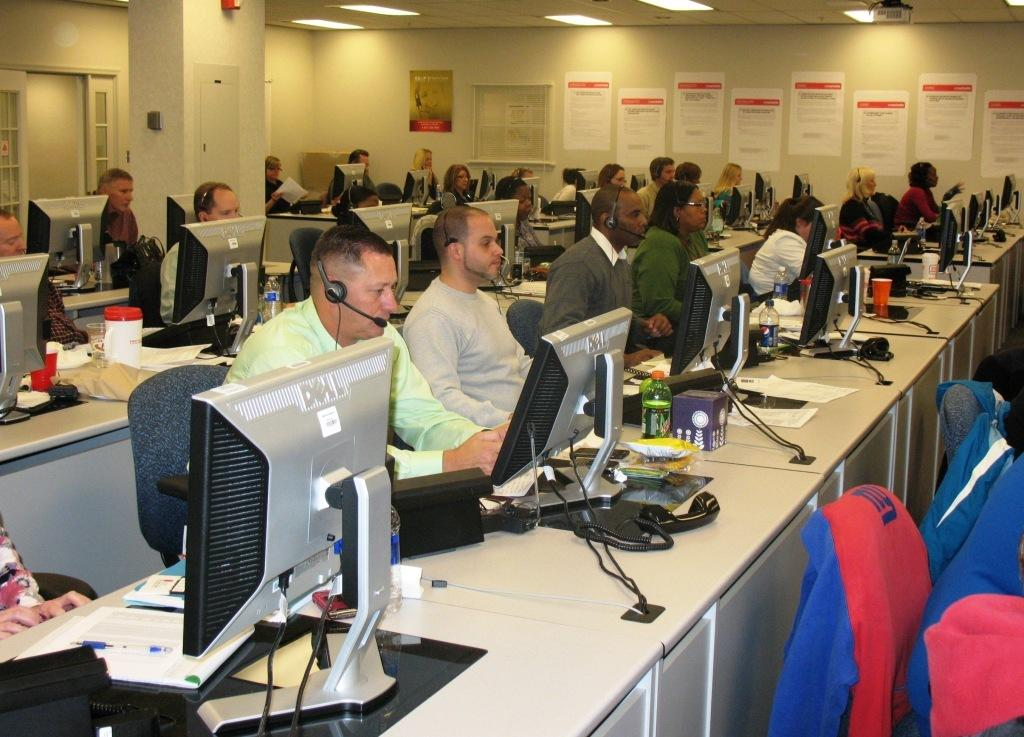<image>
Give a short and clear explanation of the subsequent image. a computer with the word Dell on the back 